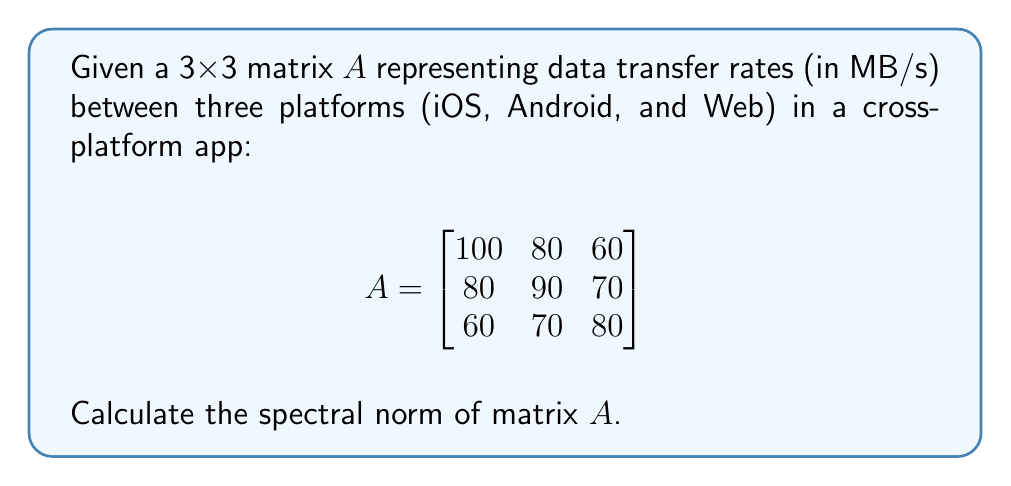Give your solution to this math problem. To calculate the spectral norm of matrix $A$, we follow these steps:

1) The spectral norm is defined as the square root of the largest eigenvalue of $A^TA$, where $A^T$ is the transpose of $A$.

2) First, calculate $A^TA$:
   $$A^TA = \begin{bmatrix}
   100 & 80 & 60 \\
   80 & 90 & 70 \\
   60 & 70 & 80
   \end{bmatrix} \begin{bmatrix}
   100 & 80 & 60 \\
   80 & 90 & 70 \\
   60 & 70 & 80
   \end{bmatrix} = \begin{bmatrix}
   22000 & 22600 & 21800 \\
   22600 & 23300 & 22400 \\
   21800 & 22400 & 21700
   \end{bmatrix}$$

3) Now, we need to find the eigenvalues of $A^TA$. The characteristic equation is:
   $$det(A^TA - \lambda I) = 0$$

4) Expanding this determinant:
   $$\begin{vmatrix}
   22000 - \lambda & 22600 & 21800 \\
   22600 & 23300 - \lambda & 22400 \\
   21800 & 22400 & 21700 - \lambda
   \end{vmatrix} = 0$$

5) This yields the cubic equation:
   $$-\lambda^3 + 67000\lambda^2 - 73100000\lambda + 1000000 = 0$$

6) Solving this equation (using a computer algebra system or numerical methods) gives us the eigenvalues:
   $$\lambda_1 \approx 66891.84, \lambda_2 \approx 107.16, \lambda_3 \approx 1.00$$

7) The largest eigenvalue is $\lambda_1 \approx 66891.84$.

8) The spectral norm is the square root of this largest eigenvalue:
   $$\text{Spectral Norm} = \sqrt{66891.84} \approx 258.64$$
Answer: $258.64$ MB/s 